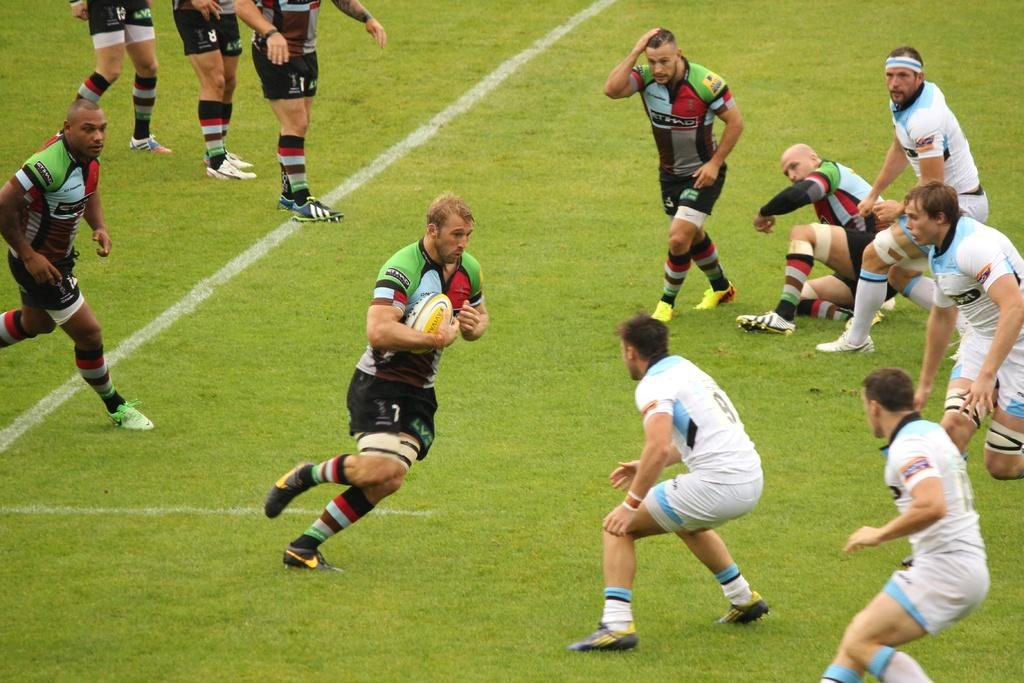<image>
Describe the image concisely. A man in a jersey has the number 9 on the back. 